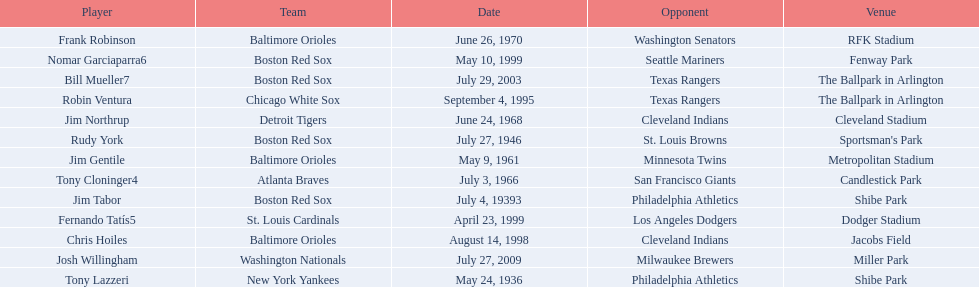On what date did the detroit tigers play the cleveland indians? June 24, 1968. 